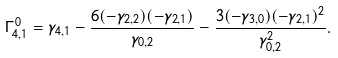Convert formula to latex. <formula><loc_0><loc_0><loc_500><loc_500>\Gamma ^ { 0 } _ { 4 , 1 } = \gamma _ { 4 , 1 } - \frac { 6 ( - \gamma _ { 2 , 2 } ) ( - \gamma _ { 2 , 1 } ) } { \gamma _ { 0 , 2 } } - \frac { 3 ( - \gamma _ { 3 , 0 } ) ( - \gamma _ { 2 , 1 } ) ^ { 2 } } { \gamma _ { 0 , 2 } ^ { 2 } } .</formula> 